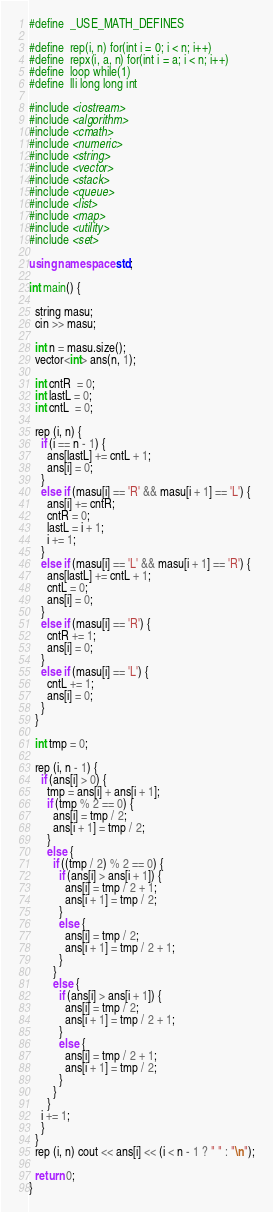Convert code to text. <code><loc_0><loc_0><loc_500><loc_500><_C++_>#define  _USE_MATH_DEFINES

#define  rep(i, n) for(int i = 0; i < n; i++)
#define  repx(i, a, n) for(int i = a; i < n; i++)
#define  loop while(1)
#define  lli long long int
 
#include <iostream>
#include <algorithm>
#include <cmath>
#include <numeric>
#include <string>
#include <vector>
#include <stack>
#include <queue>
#include <list>
#include <map>
#include <utility>
#include <set>

using namespace std;

int main() {

  string masu;
  cin >> masu;
  
  int n = masu.size();
  vector<int> ans(n, 1);

  int cntR  = 0;
  int lastL = 0;
  int cntL  = 0;

  rep (i, n) {
    if (i == n - 1) {
      ans[lastL] += cntL + 1;
      ans[i] = 0;
    }
    else if (masu[i] == 'R' && masu[i + 1] == 'L') {
      ans[i] += cntR;
      cntR = 0;
      lastL = i + 1;
      i += 1;
    }
    else if (masu[i] == 'L' && masu[i + 1] == 'R') {
      ans[lastL] += cntL + 1;
      cntL = 0;
      ans[i] = 0;
    }
    else if (masu[i] == 'R') {
      cntR += 1;
      ans[i] = 0;
    }
    else if (masu[i] == 'L') {
      cntL += 1;
      ans[i] = 0;
    }
  }
  
  int tmp = 0;

  rep (i, n - 1) {
    if (ans[i] > 0) {
      tmp = ans[i] + ans[i + 1];
      if (tmp % 2 == 0) {
        ans[i] = tmp / 2;
        ans[i + 1] = tmp / 2;
      }
      else {
        if ((tmp / 2) % 2 == 0) {
          if (ans[i] > ans[i + 1]) {
            ans[i] = tmp / 2 + 1;
            ans[i + 1] = tmp / 2;
          }
          else {
            ans[i] = tmp / 2;
            ans[i + 1] = tmp / 2 + 1;
          }
        }
        else {
          if (ans[i] > ans[i + 1]) {
            ans[i] = tmp / 2;
            ans[i + 1] = tmp / 2 + 1;
          }
          else {
            ans[i] = tmp / 2 + 1;
            ans[i + 1] = tmp / 2;
          }
        }
      }
    i += 1;
    }
  }
  rep (i, n) cout << ans[i] << (i < n - 1 ? " " : "\n");

  return 0;
}
</code> 